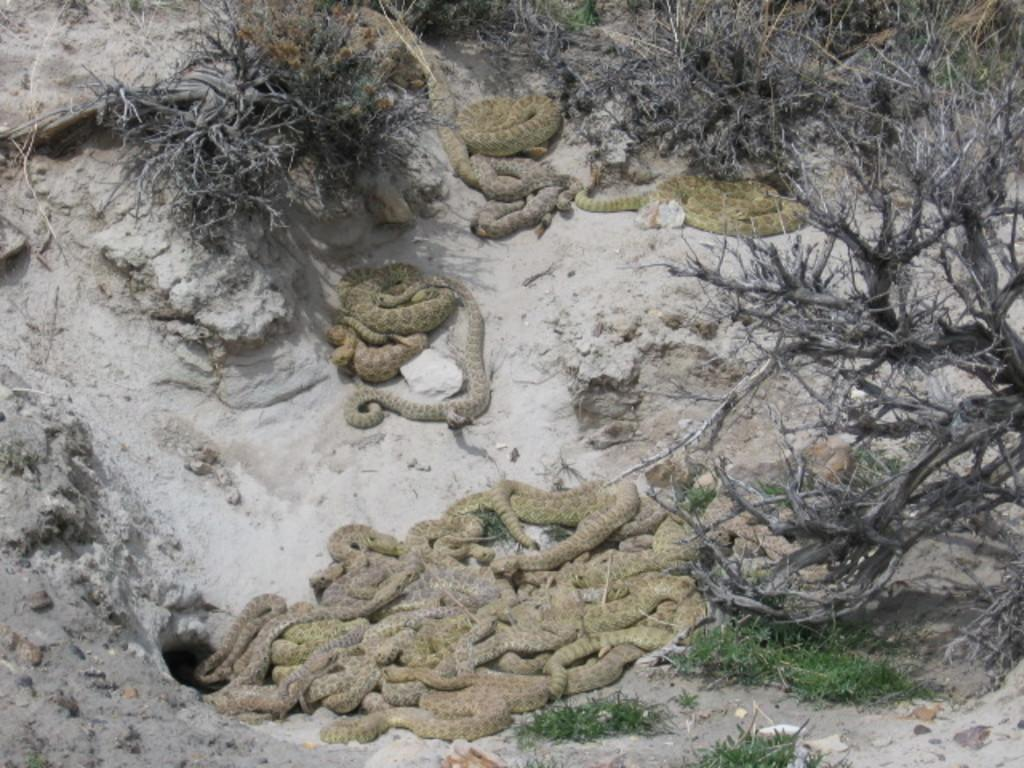What type of animals can be seen in the picture? There are snakes in the picture. What other living organisms are present in the image? There are plants in the picture. Can you describe the tree in the picture? There is a tree on the right side of the picture. What type of ocean can be seen in the picture? There is no ocean present in the picture; it features snakes, plants, and a tree. How many spoons are visible in the picture? There are no spoons present in the picture. 